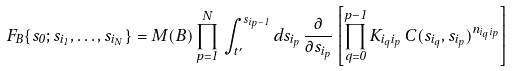Convert formula to latex. <formula><loc_0><loc_0><loc_500><loc_500>F _ { B } \{ s _ { 0 } ; s _ { i _ { 1 } } , \dots , s _ { i _ { N } } \} = M ( B ) \prod _ { p = 1 } ^ { N } \, \int _ { t ^ { \prime } } ^ { s _ { i _ { p } - 1 } } d s _ { i _ { p } } \, \frac { \partial } { \partial s _ { i _ { p } } } \left [ \prod _ { q = 0 } ^ { p - 1 } K _ { i _ { q } i _ { p } } \, C ( s _ { i _ { q } } , s _ { i _ { p } } ) ^ { n _ { i _ { q } i _ { p } } } \right ]</formula> 